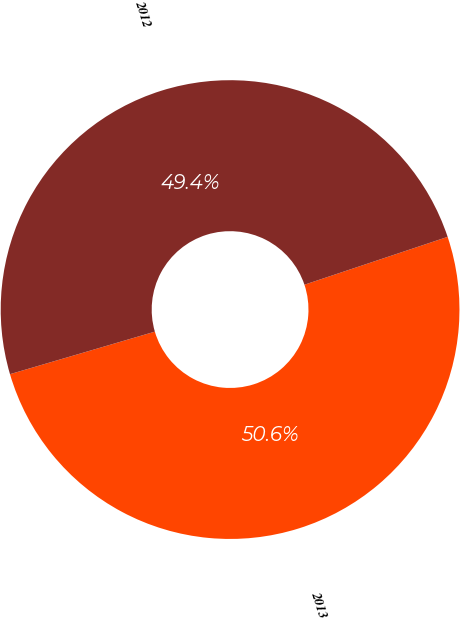Convert chart to OTSL. <chart><loc_0><loc_0><loc_500><loc_500><pie_chart><fcel>2013<fcel>2012<nl><fcel>50.59%<fcel>49.41%<nl></chart> 